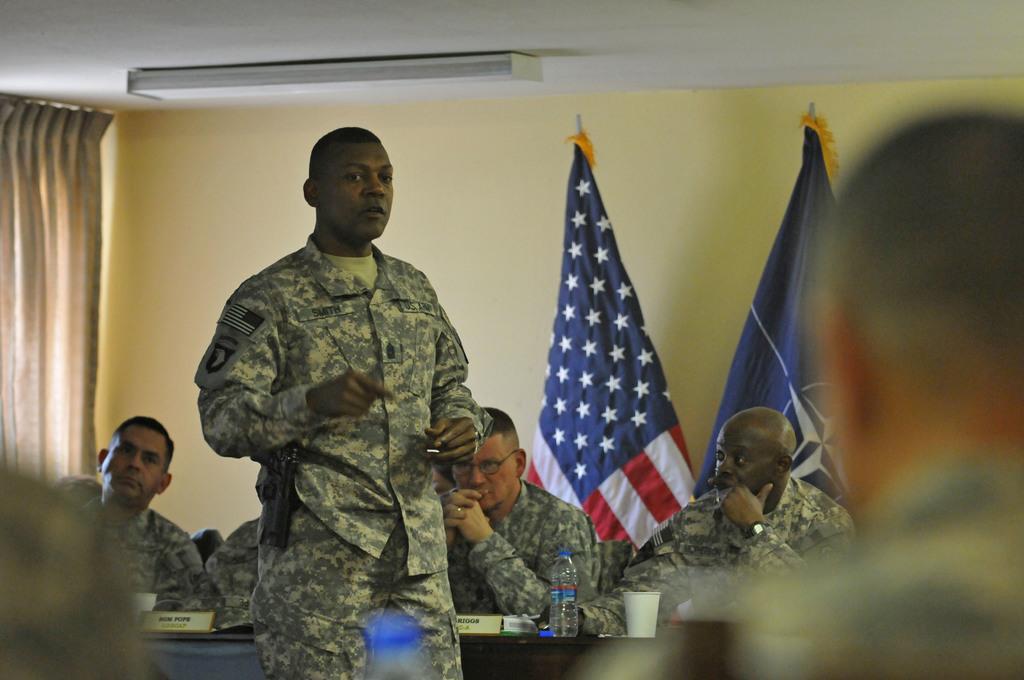Please provide a concise description of this image. In this image we can see a group of people wearing military uniforms are sitting. One person is standing. On the left side of the image we can see curtain. At the bottom of the image we can see the bottle, glass and some boards placed on the table. At the top of the image we can see lump on the roof. 